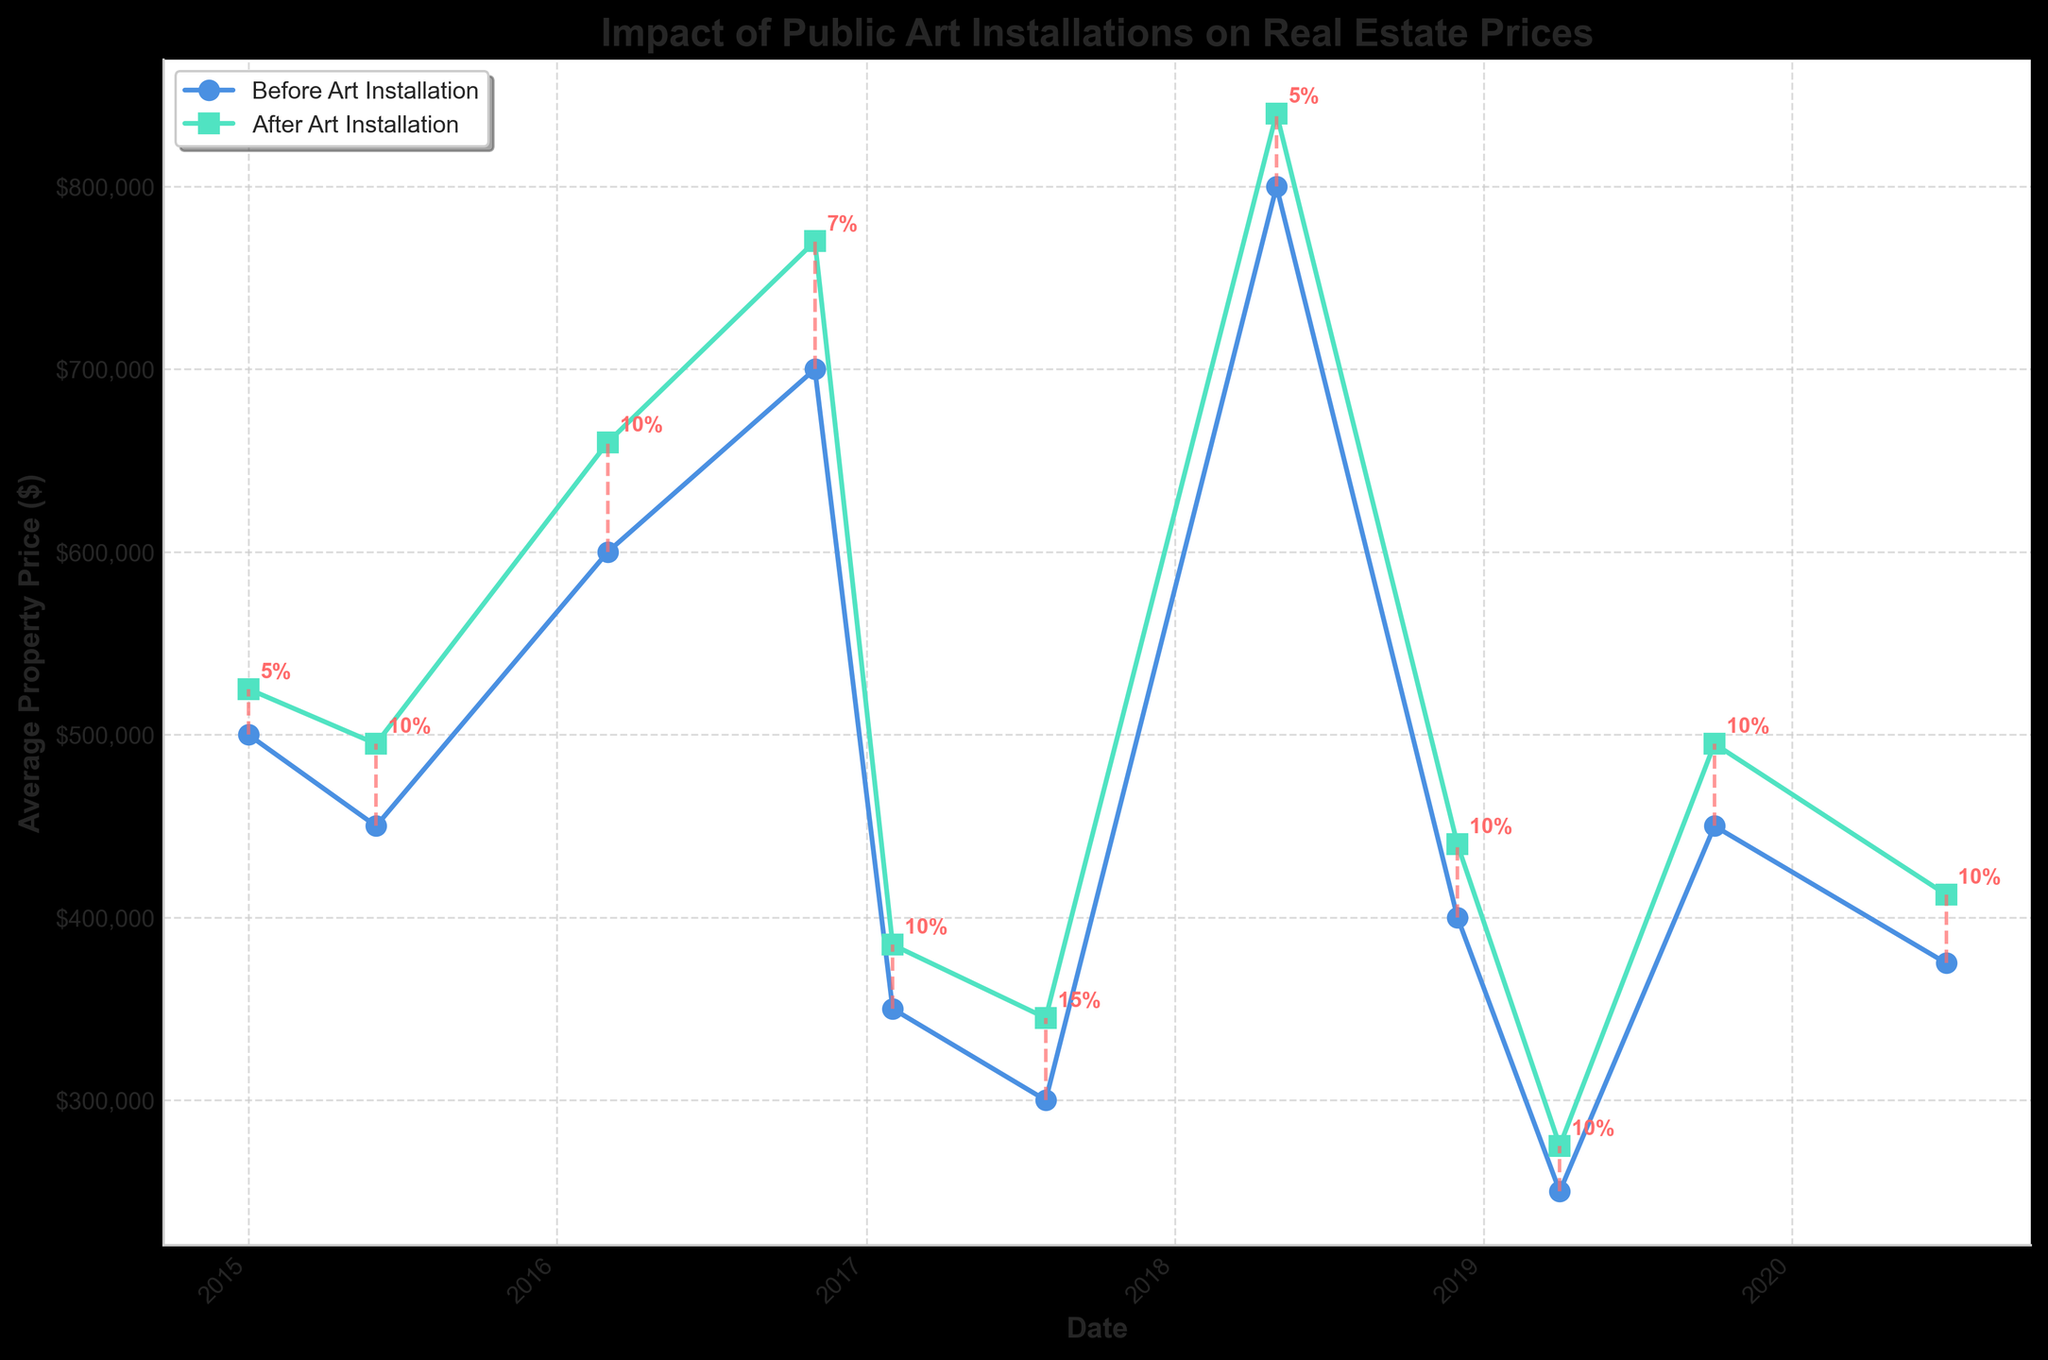What's the title of the plot? The title is at the top of the plot. It reads "Impact of Public Art Installations on Real Estate Prices".
Answer: Impact of Public Art Installations on Real Estate Prices How many data points are visualized in the plot? Each data point represents a distinct location with corresponding property prices before and after art installation. There are 11 such data points visible in the plot.
Answer: 11 Which city shows the highest average property price after the art installation, and what is the price? By inspecting the 'After Art Installation' data points, the highest value can be observed at Logan Circle, Washington DC, with an average property price of $840,000.
Answer: Logan Circle Washington DC, $840,000 Which location experienced the highest percentage increase in property prices after the art installation? By looking at the annotated percentage changes next to the after prices, Fishtown, Philadelphia shows the highest increase of 15%.
Answer: Fishtown Philadelphia, 15% What is the gap between the average property prices before and after the art installation in North Beach, San Francisco? The difference is calculated by subtracting the 'Before Art Installation' price from the 'After Art Installation' price. For North Beach, San Francisco: 770,000 - 700,000 = $70,000.
Answer: $70,000 Compare the percentage increase in property prices for Brooklyn, New York and Midtown, Atlanta. Which one is higher? From the annotations, both Brooklyn, New York and Midtown, Atlanta have a percentage increase of 10%. Thus, they have the same percentage increase.
Answer: They are equal When did Logan Circle, Washington DC experience the art installation event according to the plot? The X-axis represents dates, and by finding the corresponding point for Logan Circle, it can be observed that the event happened around May 2018.
Answer: May 2018 What's the average percentage increase in property prices across all the locations? Sum all the percentage increases and divide by the number of locations: (5 + 10 + 10 + 7 + 10 + 15 + 5 + 10 + 10 + 10 + 10) / 11 = 9.09%.
Answer: 9.09% In which year did the most art installations (data points) take place? By observing the X-axis ticks and counting the number of data points per year, it is noted that the year with the most installations is 2019, with three installations.
Answer: 2019 Can you identify two cities where the percentage increase in real estate prices was the same after the art installation? Inspecting the percentages annotated in the plot, both South Loop, Chicago, and Brooklyn, New York show a similar increase of 10%.
Answer: South Loop Chicago and Brooklyn New York 